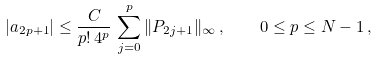Convert formula to latex. <formula><loc_0><loc_0><loc_500><loc_500>| a _ { 2 p + 1 } | \leq \frac { C } { p ! \, 4 ^ { p } } \, \sum _ { j = 0 } ^ { p } \| P _ { 2 j + 1 } \| _ { \infty } \, , \quad 0 \leq p \leq N - 1 \, ,</formula> 